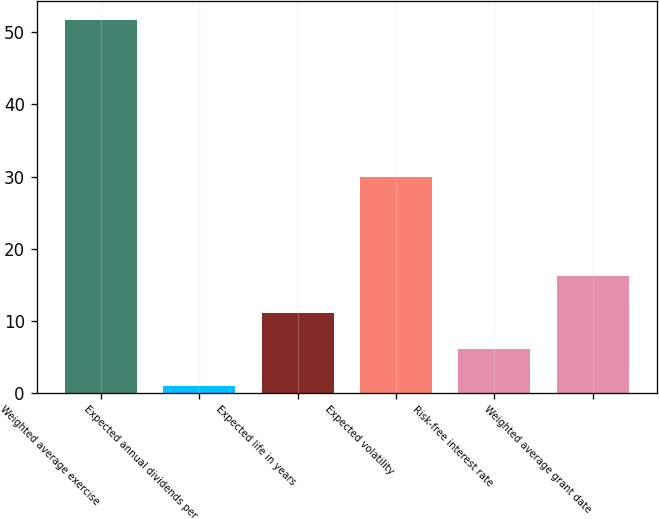<chart> <loc_0><loc_0><loc_500><loc_500><bar_chart><fcel>Weighted average exercise<fcel>Expected annual dividends per<fcel>Expected life in years<fcel>Expected volatility<fcel>Risk-free interest rate<fcel>Weighted average grant date<nl><fcel>51.74<fcel>0.96<fcel>11.12<fcel>30<fcel>6.04<fcel>16.2<nl></chart> 